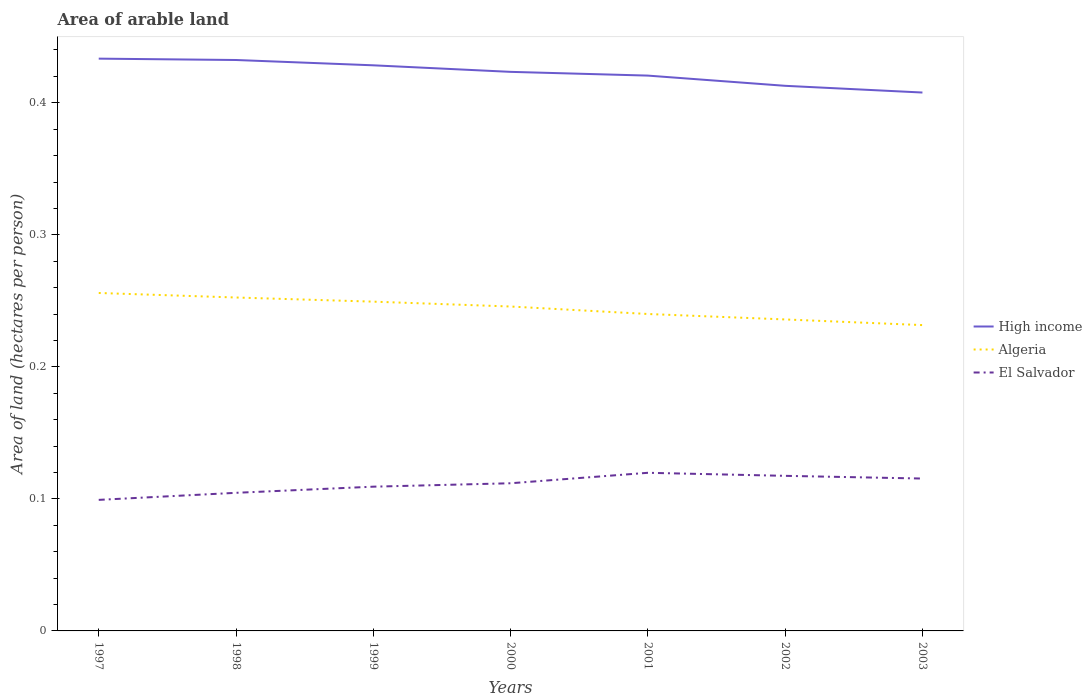Across all years, what is the maximum total arable land in El Salvador?
Provide a succinct answer. 0.1. What is the total total arable land in High income in the graph?
Provide a succinct answer. 0.01. What is the difference between the highest and the second highest total arable land in High income?
Your answer should be compact. 0.03. What is the difference between the highest and the lowest total arable land in Algeria?
Give a very brief answer. 4. Is the total arable land in High income strictly greater than the total arable land in Algeria over the years?
Provide a short and direct response. No. Are the values on the major ticks of Y-axis written in scientific E-notation?
Give a very brief answer. No. Does the graph contain any zero values?
Keep it short and to the point. No. Where does the legend appear in the graph?
Your answer should be compact. Center right. How are the legend labels stacked?
Provide a succinct answer. Vertical. What is the title of the graph?
Give a very brief answer. Area of arable land. Does "Comoros" appear as one of the legend labels in the graph?
Your answer should be very brief. No. What is the label or title of the Y-axis?
Offer a terse response. Area of land (hectares per person). What is the Area of land (hectares per person) of High income in 1997?
Make the answer very short. 0.43. What is the Area of land (hectares per person) in Algeria in 1997?
Offer a terse response. 0.26. What is the Area of land (hectares per person) in El Salvador in 1997?
Your answer should be very brief. 0.1. What is the Area of land (hectares per person) of High income in 1998?
Your answer should be very brief. 0.43. What is the Area of land (hectares per person) in Algeria in 1998?
Your answer should be very brief. 0.25. What is the Area of land (hectares per person) in El Salvador in 1998?
Your response must be concise. 0.1. What is the Area of land (hectares per person) in High income in 1999?
Offer a terse response. 0.43. What is the Area of land (hectares per person) of Algeria in 1999?
Your response must be concise. 0.25. What is the Area of land (hectares per person) in El Salvador in 1999?
Ensure brevity in your answer.  0.11. What is the Area of land (hectares per person) in High income in 2000?
Your answer should be compact. 0.42. What is the Area of land (hectares per person) in Algeria in 2000?
Your response must be concise. 0.25. What is the Area of land (hectares per person) in El Salvador in 2000?
Your response must be concise. 0.11. What is the Area of land (hectares per person) of High income in 2001?
Your answer should be compact. 0.42. What is the Area of land (hectares per person) in Algeria in 2001?
Provide a succinct answer. 0.24. What is the Area of land (hectares per person) of El Salvador in 2001?
Offer a terse response. 0.12. What is the Area of land (hectares per person) in High income in 2002?
Give a very brief answer. 0.41. What is the Area of land (hectares per person) in Algeria in 2002?
Make the answer very short. 0.24. What is the Area of land (hectares per person) of El Salvador in 2002?
Ensure brevity in your answer.  0.12. What is the Area of land (hectares per person) of High income in 2003?
Your answer should be very brief. 0.41. What is the Area of land (hectares per person) of Algeria in 2003?
Offer a terse response. 0.23. What is the Area of land (hectares per person) of El Salvador in 2003?
Ensure brevity in your answer.  0.12. Across all years, what is the maximum Area of land (hectares per person) in High income?
Your answer should be compact. 0.43. Across all years, what is the maximum Area of land (hectares per person) of Algeria?
Offer a terse response. 0.26. Across all years, what is the maximum Area of land (hectares per person) of El Salvador?
Provide a short and direct response. 0.12. Across all years, what is the minimum Area of land (hectares per person) in High income?
Your response must be concise. 0.41. Across all years, what is the minimum Area of land (hectares per person) of Algeria?
Your answer should be compact. 0.23. Across all years, what is the minimum Area of land (hectares per person) of El Salvador?
Your answer should be very brief. 0.1. What is the total Area of land (hectares per person) in High income in the graph?
Offer a terse response. 2.96. What is the total Area of land (hectares per person) in Algeria in the graph?
Your answer should be compact. 1.71. What is the total Area of land (hectares per person) of El Salvador in the graph?
Your response must be concise. 0.78. What is the difference between the Area of land (hectares per person) of High income in 1997 and that in 1998?
Make the answer very short. 0. What is the difference between the Area of land (hectares per person) of Algeria in 1997 and that in 1998?
Your response must be concise. 0. What is the difference between the Area of land (hectares per person) of El Salvador in 1997 and that in 1998?
Make the answer very short. -0.01. What is the difference between the Area of land (hectares per person) in High income in 1997 and that in 1999?
Provide a short and direct response. 0.01. What is the difference between the Area of land (hectares per person) of Algeria in 1997 and that in 1999?
Provide a short and direct response. 0.01. What is the difference between the Area of land (hectares per person) of El Salvador in 1997 and that in 1999?
Keep it short and to the point. -0.01. What is the difference between the Area of land (hectares per person) in High income in 1997 and that in 2000?
Provide a succinct answer. 0.01. What is the difference between the Area of land (hectares per person) of Algeria in 1997 and that in 2000?
Make the answer very short. 0.01. What is the difference between the Area of land (hectares per person) of El Salvador in 1997 and that in 2000?
Your answer should be very brief. -0.01. What is the difference between the Area of land (hectares per person) in High income in 1997 and that in 2001?
Provide a succinct answer. 0.01. What is the difference between the Area of land (hectares per person) of Algeria in 1997 and that in 2001?
Offer a terse response. 0.02. What is the difference between the Area of land (hectares per person) of El Salvador in 1997 and that in 2001?
Give a very brief answer. -0.02. What is the difference between the Area of land (hectares per person) of High income in 1997 and that in 2002?
Your answer should be very brief. 0.02. What is the difference between the Area of land (hectares per person) in Algeria in 1997 and that in 2002?
Make the answer very short. 0.02. What is the difference between the Area of land (hectares per person) of El Salvador in 1997 and that in 2002?
Offer a very short reply. -0.02. What is the difference between the Area of land (hectares per person) of High income in 1997 and that in 2003?
Your answer should be very brief. 0.03. What is the difference between the Area of land (hectares per person) of Algeria in 1997 and that in 2003?
Make the answer very short. 0.02. What is the difference between the Area of land (hectares per person) of El Salvador in 1997 and that in 2003?
Provide a succinct answer. -0.02. What is the difference between the Area of land (hectares per person) of High income in 1998 and that in 1999?
Provide a short and direct response. 0. What is the difference between the Area of land (hectares per person) in Algeria in 1998 and that in 1999?
Provide a succinct answer. 0. What is the difference between the Area of land (hectares per person) in El Salvador in 1998 and that in 1999?
Offer a terse response. -0. What is the difference between the Area of land (hectares per person) in High income in 1998 and that in 2000?
Your answer should be very brief. 0.01. What is the difference between the Area of land (hectares per person) in Algeria in 1998 and that in 2000?
Your response must be concise. 0.01. What is the difference between the Area of land (hectares per person) in El Salvador in 1998 and that in 2000?
Your response must be concise. -0.01. What is the difference between the Area of land (hectares per person) of High income in 1998 and that in 2001?
Offer a very short reply. 0.01. What is the difference between the Area of land (hectares per person) in Algeria in 1998 and that in 2001?
Provide a short and direct response. 0.01. What is the difference between the Area of land (hectares per person) in El Salvador in 1998 and that in 2001?
Make the answer very short. -0.02. What is the difference between the Area of land (hectares per person) of High income in 1998 and that in 2002?
Give a very brief answer. 0.02. What is the difference between the Area of land (hectares per person) of Algeria in 1998 and that in 2002?
Your answer should be compact. 0.02. What is the difference between the Area of land (hectares per person) of El Salvador in 1998 and that in 2002?
Ensure brevity in your answer.  -0.01. What is the difference between the Area of land (hectares per person) of High income in 1998 and that in 2003?
Keep it short and to the point. 0.02. What is the difference between the Area of land (hectares per person) in Algeria in 1998 and that in 2003?
Offer a very short reply. 0.02. What is the difference between the Area of land (hectares per person) in El Salvador in 1998 and that in 2003?
Provide a succinct answer. -0.01. What is the difference between the Area of land (hectares per person) in High income in 1999 and that in 2000?
Keep it short and to the point. 0.01. What is the difference between the Area of land (hectares per person) in Algeria in 1999 and that in 2000?
Your answer should be compact. 0. What is the difference between the Area of land (hectares per person) of El Salvador in 1999 and that in 2000?
Make the answer very short. -0. What is the difference between the Area of land (hectares per person) of High income in 1999 and that in 2001?
Your answer should be very brief. 0.01. What is the difference between the Area of land (hectares per person) in Algeria in 1999 and that in 2001?
Your response must be concise. 0.01. What is the difference between the Area of land (hectares per person) in El Salvador in 1999 and that in 2001?
Make the answer very short. -0.01. What is the difference between the Area of land (hectares per person) of High income in 1999 and that in 2002?
Your answer should be compact. 0.02. What is the difference between the Area of land (hectares per person) in Algeria in 1999 and that in 2002?
Provide a short and direct response. 0.01. What is the difference between the Area of land (hectares per person) in El Salvador in 1999 and that in 2002?
Keep it short and to the point. -0.01. What is the difference between the Area of land (hectares per person) of High income in 1999 and that in 2003?
Offer a terse response. 0.02. What is the difference between the Area of land (hectares per person) of Algeria in 1999 and that in 2003?
Keep it short and to the point. 0.02. What is the difference between the Area of land (hectares per person) in El Salvador in 1999 and that in 2003?
Offer a very short reply. -0.01. What is the difference between the Area of land (hectares per person) of High income in 2000 and that in 2001?
Your answer should be very brief. 0. What is the difference between the Area of land (hectares per person) in Algeria in 2000 and that in 2001?
Offer a very short reply. 0.01. What is the difference between the Area of land (hectares per person) of El Salvador in 2000 and that in 2001?
Offer a terse response. -0.01. What is the difference between the Area of land (hectares per person) of High income in 2000 and that in 2002?
Your answer should be compact. 0.01. What is the difference between the Area of land (hectares per person) of Algeria in 2000 and that in 2002?
Make the answer very short. 0.01. What is the difference between the Area of land (hectares per person) in El Salvador in 2000 and that in 2002?
Your response must be concise. -0.01. What is the difference between the Area of land (hectares per person) in High income in 2000 and that in 2003?
Provide a short and direct response. 0.02. What is the difference between the Area of land (hectares per person) of Algeria in 2000 and that in 2003?
Ensure brevity in your answer.  0.01. What is the difference between the Area of land (hectares per person) in El Salvador in 2000 and that in 2003?
Your answer should be compact. -0. What is the difference between the Area of land (hectares per person) of High income in 2001 and that in 2002?
Your answer should be compact. 0.01. What is the difference between the Area of land (hectares per person) of Algeria in 2001 and that in 2002?
Your answer should be very brief. 0. What is the difference between the Area of land (hectares per person) of El Salvador in 2001 and that in 2002?
Offer a terse response. 0. What is the difference between the Area of land (hectares per person) of High income in 2001 and that in 2003?
Your answer should be very brief. 0.01. What is the difference between the Area of land (hectares per person) of Algeria in 2001 and that in 2003?
Your answer should be very brief. 0.01. What is the difference between the Area of land (hectares per person) of El Salvador in 2001 and that in 2003?
Make the answer very short. 0. What is the difference between the Area of land (hectares per person) in High income in 2002 and that in 2003?
Your answer should be very brief. 0.01. What is the difference between the Area of land (hectares per person) in Algeria in 2002 and that in 2003?
Offer a very short reply. 0. What is the difference between the Area of land (hectares per person) of El Salvador in 2002 and that in 2003?
Your answer should be compact. 0. What is the difference between the Area of land (hectares per person) in High income in 1997 and the Area of land (hectares per person) in Algeria in 1998?
Your response must be concise. 0.18. What is the difference between the Area of land (hectares per person) in High income in 1997 and the Area of land (hectares per person) in El Salvador in 1998?
Make the answer very short. 0.33. What is the difference between the Area of land (hectares per person) of Algeria in 1997 and the Area of land (hectares per person) of El Salvador in 1998?
Your response must be concise. 0.15. What is the difference between the Area of land (hectares per person) of High income in 1997 and the Area of land (hectares per person) of Algeria in 1999?
Make the answer very short. 0.18. What is the difference between the Area of land (hectares per person) in High income in 1997 and the Area of land (hectares per person) in El Salvador in 1999?
Provide a short and direct response. 0.32. What is the difference between the Area of land (hectares per person) of Algeria in 1997 and the Area of land (hectares per person) of El Salvador in 1999?
Make the answer very short. 0.15. What is the difference between the Area of land (hectares per person) in High income in 1997 and the Area of land (hectares per person) in Algeria in 2000?
Your answer should be compact. 0.19. What is the difference between the Area of land (hectares per person) in High income in 1997 and the Area of land (hectares per person) in El Salvador in 2000?
Ensure brevity in your answer.  0.32. What is the difference between the Area of land (hectares per person) of Algeria in 1997 and the Area of land (hectares per person) of El Salvador in 2000?
Your answer should be very brief. 0.14. What is the difference between the Area of land (hectares per person) in High income in 1997 and the Area of land (hectares per person) in Algeria in 2001?
Make the answer very short. 0.19. What is the difference between the Area of land (hectares per person) in High income in 1997 and the Area of land (hectares per person) in El Salvador in 2001?
Offer a terse response. 0.31. What is the difference between the Area of land (hectares per person) of Algeria in 1997 and the Area of land (hectares per person) of El Salvador in 2001?
Your response must be concise. 0.14. What is the difference between the Area of land (hectares per person) of High income in 1997 and the Area of land (hectares per person) of Algeria in 2002?
Your response must be concise. 0.2. What is the difference between the Area of land (hectares per person) in High income in 1997 and the Area of land (hectares per person) in El Salvador in 2002?
Give a very brief answer. 0.32. What is the difference between the Area of land (hectares per person) of Algeria in 1997 and the Area of land (hectares per person) of El Salvador in 2002?
Offer a very short reply. 0.14. What is the difference between the Area of land (hectares per person) of High income in 1997 and the Area of land (hectares per person) of Algeria in 2003?
Provide a short and direct response. 0.2. What is the difference between the Area of land (hectares per person) of High income in 1997 and the Area of land (hectares per person) of El Salvador in 2003?
Make the answer very short. 0.32. What is the difference between the Area of land (hectares per person) of Algeria in 1997 and the Area of land (hectares per person) of El Salvador in 2003?
Offer a very short reply. 0.14. What is the difference between the Area of land (hectares per person) of High income in 1998 and the Area of land (hectares per person) of Algeria in 1999?
Your answer should be very brief. 0.18. What is the difference between the Area of land (hectares per person) of High income in 1998 and the Area of land (hectares per person) of El Salvador in 1999?
Your response must be concise. 0.32. What is the difference between the Area of land (hectares per person) in Algeria in 1998 and the Area of land (hectares per person) in El Salvador in 1999?
Provide a succinct answer. 0.14. What is the difference between the Area of land (hectares per person) of High income in 1998 and the Area of land (hectares per person) of Algeria in 2000?
Ensure brevity in your answer.  0.19. What is the difference between the Area of land (hectares per person) of High income in 1998 and the Area of land (hectares per person) of El Salvador in 2000?
Give a very brief answer. 0.32. What is the difference between the Area of land (hectares per person) in Algeria in 1998 and the Area of land (hectares per person) in El Salvador in 2000?
Give a very brief answer. 0.14. What is the difference between the Area of land (hectares per person) in High income in 1998 and the Area of land (hectares per person) in Algeria in 2001?
Provide a succinct answer. 0.19. What is the difference between the Area of land (hectares per person) in High income in 1998 and the Area of land (hectares per person) in El Salvador in 2001?
Your response must be concise. 0.31. What is the difference between the Area of land (hectares per person) in Algeria in 1998 and the Area of land (hectares per person) in El Salvador in 2001?
Your answer should be very brief. 0.13. What is the difference between the Area of land (hectares per person) of High income in 1998 and the Area of land (hectares per person) of Algeria in 2002?
Your answer should be very brief. 0.2. What is the difference between the Area of land (hectares per person) of High income in 1998 and the Area of land (hectares per person) of El Salvador in 2002?
Provide a short and direct response. 0.32. What is the difference between the Area of land (hectares per person) of Algeria in 1998 and the Area of land (hectares per person) of El Salvador in 2002?
Keep it short and to the point. 0.14. What is the difference between the Area of land (hectares per person) in High income in 1998 and the Area of land (hectares per person) in Algeria in 2003?
Provide a short and direct response. 0.2. What is the difference between the Area of land (hectares per person) in High income in 1998 and the Area of land (hectares per person) in El Salvador in 2003?
Provide a short and direct response. 0.32. What is the difference between the Area of land (hectares per person) in Algeria in 1998 and the Area of land (hectares per person) in El Salvador in 2003?
Your answer should be compact. 0.14. What is the difference between the Area of land (hectares per person) in High income in 1999 and the Area of land (hectares per person) in Algeria in 2000?
Provide a short and direct response. 0.18. What is the difference between the Area of land (hectares per person) of High income in 1999 and the Area of land (hectares per person) of El Salvador in 2000?
Your answer should be compact. 0.32. What is the difference between the Area of land (hectares per person) of Algeria in 1999 and the Area of land (hectares per person) of El Salvador in 2000?
Offer a very short reply. 0.14. What is the difference between the Area of land (hectares per person) of High income in 1999 and the Area of land (hectares per person) of Algeria in 2001?
Keep it short and to the point. 0.19. What is the difference between the Area of land (hectares per person) in High income in 1999 and the Area of land (hectares per person) in El Salvador in 2001?
Provide a succinct answer. 0.31. What is the difference between the Area of land (hectares per person) in Algeria in 1999 and the Area of land (hectares per person) in El Salvador in 2001?
Give a very brief answer. 0.13. What is the difference between the Area of land (hectares per person) of High income in 1999 and the Area of land (hectares per person) of Algeria in 2002?
Give a very brief answer. 0.19. What is the difference between the Area of land (hectares per person) of High income in 1999 and the Area of land (hectares per person) of El Salvador in 2002?
Provide a succinct answer. 0.31. What is the difference between the Area of land (hectares per person) of Algeria in 1999 and the Area of land (hectares per person) of El Salvador in 2002?
Ensure brevity in your answer.  0.13. What is the difference between the Area of land (hectares per person) of High income in 1999 and the Area of land (hectares per person) of Algeria in 2003?
Ensure brevity in your answer.  0.2. What is the difference between the Area of land (hectares per person) of High income in 1999 and the Area of land (hectares per person) of El Salvador in 2003?
Give a very brief answer. 0.31. What is the difference between the Area of land (hectares per person) of Algeria in 1999 and the Area of land (hectares per person) of El Salvador in 2003?
Your answer should be compact. 0.13. What is the difference between the Area of land (hectares per person) of High income in 2000 and the Area of land (hectares per person) of Algeria in 2001?
Make the answer very short. 0.18. What is the difference between the Area of land (hectares per person) of High income in 2000 and the Area of land (hectares per person) of El Salvador in 2001?
Offer a terse response. 0.3. What is the difference between the Area of land (hectares per person) of Algeria in 2000 and the Area of land (hectares per person) of El Salvador in 2001?
Your answer should be compact. 0.13. What is the difference between the Area of land (hectares per person) in High income in 2000 and the Area of land (hectares per person) in Algeria in 2002?
Your answer should be very brief. 0.19. What is the difference between the Area of land (hectares per person) of High income in 2000 and the Area of land (hectares per person) of El Salvador in 2002?
Give a very brief answer. 0.31. What is the difference between the Area of land (hectares per person) of Algeria in 2000 and the Area of land (hectares per person) of El Salvador in 2002?
Provide a succinct answer. 0.13. What is the difference between the Area of land (hectares per person) in High income in 2000 and the Area of land (hectares per person) in Algeria in 2003?
Your answer should be very brief. 0.19. What is the difference between the Area of land (hectares per person) in High income in 2000 and the Area of land (hectares per person) in El Salvador in 2003?
Make the answer very short. 0.31. What is the difference between the Area of land (hectares per person) in Algeria in 2000 and the Area of land (hectares per person) in El Salvador in 2003?
Offer a very short reply. 0.13. What is the difference between the Area of land (hectares per person) in High income in 2001 and the Area of land (hectares per person) in Algeria in 2002?
Offer a very short reply. 0.18. What is the difference between the Area of land (hectares per person) in High income in 2001 and the Area of land (hectares per person) in El Salvador in 2002?
Offer a very short reply. 0.3. What is the difference between the Area of land (hectares per person) in Algeria in 2001 and the Area of land (hectares per person) in El Salvador in 2002?
Give a very brief answer. 0.12. What is the difference between the Area of land (hectares per person) in High income in 2001 and the Area of land (hectares per person) in Algeria in 2003?
Offer a very short reply. 0.19. What is the difference between the Area of land (hectares per person) of High income in 2001 and the Area of land (hectares per person) of El Salvador in 2003?
Give a very brief answer. 0.31. What is the difference between the Area of land (hectares per person) of Algeria in 2001 and the Area of land (hectares per person) of El Salvador in 2003?
Provide a short and direct response. 0.12. What is the difference between the Area of land (hectares per person) in High income in 2002 and the Area of land (hectares per person) in Algeria in 2003?
Make the answer very short. 0.18. What is the difference between the Area of land (hectares per person) in High income in 2002 and the Area of land (hectares per person) in El Salvador in 2003?
Your answer should be compact. 0.3. What is the difference between the Area of land (hectares per person) of Algeria in 2002 and the Area of land (hectares per person) of El Salvador in 2003?
Offer a very short reply. 0.12. What is the average Area of land (hectares per person) of High income per year?
Give a very brief answer. 0.42. What is the average Area of land (hectares per person) in Algeria per year?
Provide a short and direct response. 0.24. What is the average Area of land (hectares per person) of El Salvador per year?
Your response must be concise. 0.11. In the year 1997, what is the difference between the Area of land (hectares per person) in High income and Area of land (hectares per person) in Algeria?
Provide a short and direct response. 0.18. In the year 1997, what is the difference between the Area of land (hectares per person) of High income and Area of land (hectares per person) of El Salvador?
Offer a very short reply. 0.33. In the year 1997, what is the difference between the Area of land (hectares per person) of Algeria and Area of land (hectares per person) of El Salvador?
Make the answer very short. 0.16. In the year 1998, what is the difference between the Area of land (hectares per person) in High income and Area of land (hectares per person) in Algeria?
Give a very brief answer. 0.18. In the year 1998, what is the difference between the Area of land (hectares per person) of High income and Area of land (hectares per person) of El Salvador?
Offer a terse response. 0.33. In the year 1998, what is the difference between the Area of land (hectares per person) in Algeria and Area of land (hectares per person) in El Salvador?
Your answer should be compact. 0.15. In the year 1999, what is the difference between the Area of land (hectares per person) of High income and Area of land (hectares per person) of Algeria?
Your answer should be compact. 0.18. In the year 1999, what is the difference between the Area of land (hectares per person) in High income and Area of land (hectares per person) in El Salvador?
Your answer should be very brief. 0.32. In the year 1999, what is the difference between the Area of land (hectares per person) of Algeria and Area of land (hectares per person) of El Salvador?
Your answer should be very brief. 0.14. In the year 2000, what is the difference between the Area of land (hectares per person) in High income and Area of land (hectares per person) in Algeria?
Give a very brief answer. 0.18. In the year 2000, what is the difference between the Area of land (hectares per person) of High income and Area of land (hectares per person) of El Salvador?
Give a very brief answer. 0.31. In the year 2000, what is the difference between the Area of land (hectares per person) of Algeria and Area of land (hectares per person) of El Salvador?
Offer a very short reply. 0.13. In the year 2001, what is the difference between the Area of land (hectares per person) of High income and Area of land (hectares per person) of Algeria?
Your answer should be compact. 0.18. In the year 2001, what is the difference between the Area of land (hectares per person) of High income and Area of land (hectares per person) of El Salvador?
Ensure brevity in your answer.  0.3. In the year 2001, what is the difference between the Area of land (hectares per person) of Algeria and Area of land (hectares per person) of El Salvador?
Offer a terse response. 0.12. In the year 2002, what is the difference between the Area of land (hectares per person) in High income and Area of land (hectares per person) in Algeria?
Give a very brief answer. 0.18. In the year 2002, what is the difference between the Area of land (hectares per person) in High income and Area of land (hectares per person) in El Salvador?
Offer a terse response. 0.3. In the year 2002, what is the difference between the Area of land (hectares per person) of Algeria and Area of land (hectares per person) of El Salvador?
Your answer should be compact. 0.12. In the year 2003, what is the difference between the Area of land (hectares per person) in High income and Area of land (hectares per person) in Algeria?
Your response must be concise. 0.18. In the year 2003, what is the difference between the Area of land (hectares per person) in High income and Area of land (hectares per person) in El Salvador?
Keep it short and to the point. 0.29. In the year 2003, what is the difference between the Area of land (hectares per person) of Algeria and Area of land (hectares per person) of El Salvador?
Offer a very short reply. 0.12. What is the ratio of the Area of land (hectares per person) of High income in 1997 to that in 1998?
Provide a short and direct response. 1. What is the ratio of the Area of land (hectares per person) in Algeria in 1997 to that in 1998?
Your answer should be compact. 1.01. What is the ratio of the Area of land (hectares per person) in El Salvador in 1997 to that in 1998?
Provide a short and direct response. 0.95. What is the ratio of the Area of land (hectares per person) in High income in 1997 to that in 1999?
Offer a very short reply. 1.01. What is the ratio of the Area of land (hectares per person) in Algeria in 1997 to that in 1999?
Your response must be concise. 1.03. What is the ratio of the Area of land (hectares per person) of El Salvador in 1997 to that in 1999?
Provide a short and direct response. 0.91. What is the ratio of the Area of land (hectares per person) of High income in 1997 to that in 2000?
Make the answer very short. 1.02. What is the ratio of the Area of land (hectares per person) in Algeria in 1997 to that in 2000?
Give a very brief answer. 1.04. What is the ratio of the Area of land (hectares per person) in El Salvador in 1997 to that in 2000?
Your answer should be compact. 0.89. What is the ratio of the Area of land (hectares per person) in High income in 1997 to that in 2001?
Your answer should be very brief. 1.03. What is the ratio of the Area of land (hectares per person) in Algeria in 1997 to that in 2001?
Make the answer very short. 1.07. What is the ratio of the Area of land (hectares per person) of El Salvador in 1997 to that in 2001?
Provide a succinct answer. 0.83. What is the ratio of the Area of land (hectares per person) of High income in 1997 to that in 2002?
Offer a very short reply. 1.05. What is the ratio of the Area of land (hectares per person) in Algeria in 1997 to that in 2002?
Give a very brief answer. 1.08. What is the ratio of the Area of land (hectares per person) of El Salvador in 1997 to that in 2002?
Offer a terse response. 0.84. What is the ratio of the Area of land (hectares per person) in High income in 1997 to that in 2003?
Provide a short and direct response. 1.06. What is the ratio of the Area of land (hectares per person) in Algeria in 1997 to that in 2003?
Your answer should be very brief. 1.1. What is the ratio of the Area of land (hectares per person) of El Salvador in 1997 to that in 2003?
Ensure brevity in your answer.  0.86. What is the ratio of the Area of land (hectares per person) of High income in 1998 to that in 1999?
Provide a succinct answer. 1.01. What is the ratio of the Area of land (hectares per person) of Algeria in 1998 to that in 1999?
Keep it short and to the point. 1.01. What is the ratio of the Area of land (hectares per person) of El Salvador in 1998 to that in 1999?
Your response must be concise. 0.96. What is the ratio of the Area of land (hectares per person) in High income in 1998 to that in 2000?
Make the answer very short. 1.02. What is the ratio of the Area of land (hectares per person) in Algeria in 1998 to that in 2000?
Keep it short and to the point. 1.03. What is the ratio of the Area of land (hectares per person) of El Salvador in 1998 to that in 2000?
Your answer should be very brief. 0.94. What is the ratio of the Area of land (hectares per person) of High income in 1998 to that in 2001?
Your response must be concise. 1.03. What is the ratio of the Area of land (hectares per person) of Algeria in 1998 to that in 2001?
Provide a short and direct response. 1.05. What is the ratio of the Area of land (hectares per person) of El Salvador in 1998 to that in 2001?
Provide a succinct answer. 0.87. What is the ratio of the Area of land (hectares per person) in High income in 1998 to that in 2002?
Make the answer very short. 1.05. What is the ratio of the Area of land (hectares per person) of Algeria in 1998 to that in 2002?
Ensure brevity in your answer.  1.07. What is the ratio of the Area of land (hectares per person) in El Salvador in 1998 to that in 2002?
Provide a succinct answer. 0.89. What is the ratio of the Area of land (hectares per person) of High income in 1998 to that in 2003?
Ensure brevity in your answer.  1.06. What is the ratio of the Area of land (hectares per person) of Algeria in 1998 to that in 2003?
Provide a succinct answer. 1.09. What is the ratio of the Area of land (hectares per person) of El Salvador in 1998 to that in 2003?
Offer a terse response. 0.91. What is the ratio of the Area of land (hectares per person) of High income in 1999 to that in 2000?
Offer a terse response. 1.01. What is the ratio of the Area of land (hectares per person) of El Salvador in 1999 to that in 2000?
Make the answer very short. 0.98. What is the ratio of the Area of land (hectares per person) of High income in 1999 to that in 2001?
Your answer should be compact. 1.02. What is the ratio of the Area of land (hectares per person) of Algeria in 1999 to that in 2001?
Provide a short and direct response. 1.04. What is the ratio of the Area of land (hectares per person) of El Salvador in 1999 to that in 2001?
Offer a very short reply. 0.91. What is the ratio of the Area of land (hectares per person) in High income in 1999 to that in 2002?
Provide a short and direct response. 1.04. What is the ratio of the Area of land (hectares per person) in Algeria in 1999 to that in 2002?
Offer a very short reply. 1.06. What is the ratio of the Area of land (hectares per person) in El Salvador in 1999 to that in 2002?
Your answer should be compact. 0.93. What is the ratio of the Area of land (hectares per person) in High income in 1999 to that in 2003?
Provide a succinct answer. 1.05. What is the ratio of the Area of land (hectares per person) in Algeria in 1999 to that in 2003?
Offer a very short reply. 1.08. What is the ratio of the Area of land (hectares per person) of El Salvador in 1999 to that in 2003?
Ensure brevity in your answer.  0.95. What is the ratio of the Area of land (hectares per person) of High income in 2000 to that in 2001?
Keep it short and to the point. 1.01. What is the ratio of the Area of land (hectares per person) of Algeria in 2000 to that in 2001?
Provide a short and direct response. 1.02. What is the ratio of the Area of land (hectares per person) in El Salvador in 2000 to that in 2001?
Ensure brevity in your answer.  0.93. What is the ratio of the Area of land (hectares per person) in High income in 2000 to that in 2002?
Provide a succinct answer. 1.03. What is the ratio of the Area of land (hectares per person) of Algeria in 2000 to that in 2002?
Offer a terse response. 1.04. What is the ratio of the Area of land (hectares per person) in El Salvador in 2000 to that in 2002?
Your answer should be very brief. 0.95. What is the ratio of the Area of land (hectares per person) in High income in 2000 to that in 2003?
Make the answer very short. 1.04. What is the ratio of the Area of land (hectares per person) in Algeria in 2000 to that in 2003?
Your response must be concise. 1.06. What is the ratio of the Area of land (hectares per person) in El Salvador in 2000 to that in 2003?
Provide a succinct answer. 0.97. What is the ratio of the Area of land (hectares per person) of High income in 2001 to that in 2002?
Provide a short and direct response. 1.02. What is the ratio of the Area of land (hectares per person) of Algeria in 2001 to that in 2002?
Provide a short and direct response. 1.02. What is the ratio of the Area of land (hectares per person) of El Salvador in 2001 to that in 2002?
Provide a succinct answer. 1.02. What is the ratio of the Area of land (hectares per person) of High income in 2001 to that in 2003?
Make the answer very short. 1.03. What is the ratio of the Area of land (hectares per person) of Algeria in 2001 to that in 2003?
Your answer should be very brief. 1.04. What is the ratio of the Area of land (hectares per person) of El Salvador in 2001 to that in 2003?
Your response must be concise. 1.04. What is the ratio of the Area of land (hectares per person) of High income in 2002 to that in 2003?
Make the answer very short. 1.01. What is the ratio of the Area of land (hectares per person) of Algeria in 2002 to that in 2003?
Offer a terse response. 1.02. What is the ratio of the Area of land (hectares per person) in El Salvador in 2002 to that in 2003?
Your response must be concise. 1.02. What is the difference between the highest and the second highest Area of land (hectares per person) of Algeria?
Your answer should be compact. 0. What is the difference between the highest and the second highest Area of land (hectares per person) of El Salvador?
Your response must be concise. 0. What is the difference between the highest and the lowest Area of land (hectares per person) in High income?
Provide a succinct answer. 0.03. What is the difference between the highest and the lowest Area of land (hectares per person) in Algeria?
Offer a terse response. 0.02. What is the difference between the highest and the lowest Area of land (hectares per person) of El Salvador?
Your response must be concise. 0.02. 